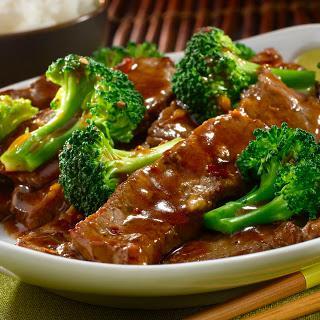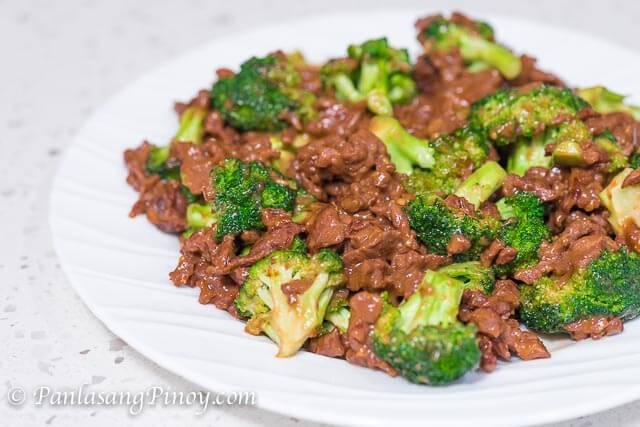The first image is the image on the left, the second image is the image on the right. For the images shown, is this caption "Broccoli stir fry is being served in the center of two white plates." true? Answer yes or no. Yes. The first image is the image on the left, the second image is the image on the right. Considering the images on both sides, is "The left and right image contains the same number of white plates with broccoli and beef." valid? Answer yes or no. Yes. 